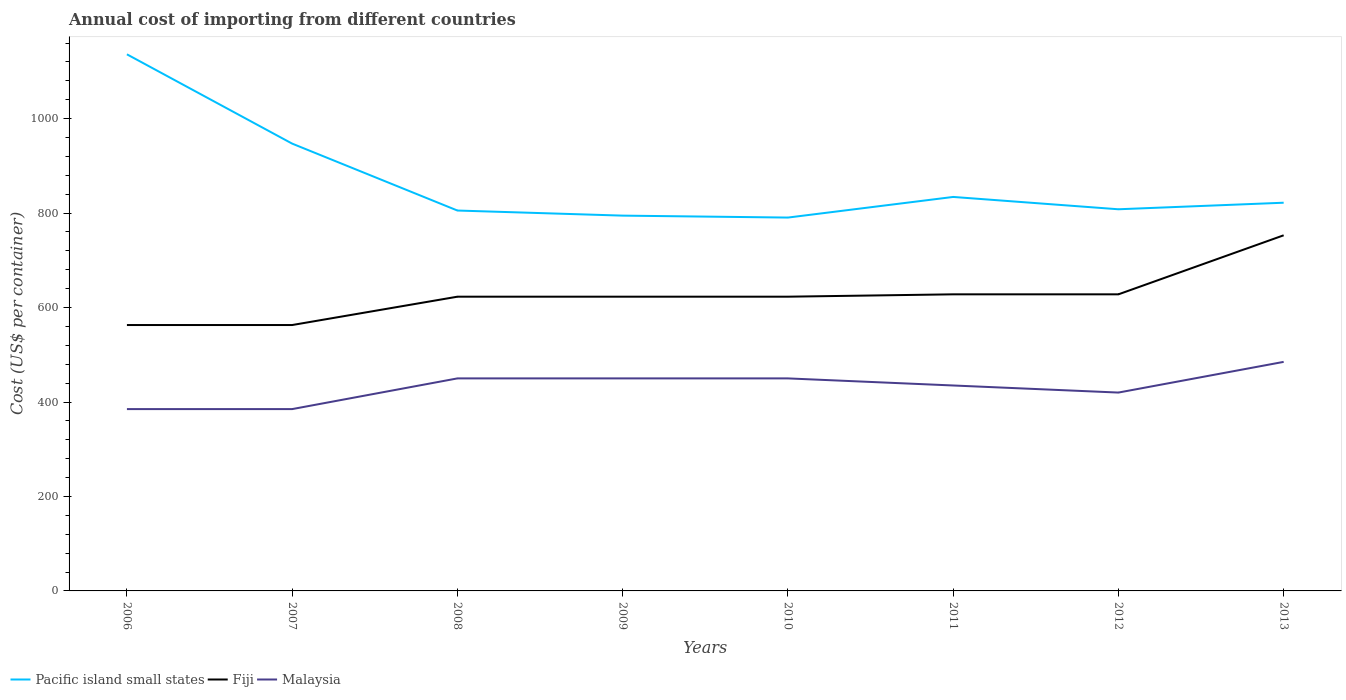Does the line corresponding to Pacific island small states intersect with the line corresponding to Fiji?
Offer a very short reply. No. Is the number of lines equal to the number of legend labels?
Provide a succinct answer. Yes. Across all years, what is the maximum total annual cost of importing in Fiji?
Your response must be concise. 563. What is the total total annual cost of importing in Malaysia in the graph?
Offer a terse response. -50. What is the difference between the highest and the second highest total annual cost of importing in Pacific island small states?
Offer a very short reply. 345.67. How many lines are there?
Provide a short and direct response. 3. How many years are there in the graph?
Your response must be concise. 8. What is the difference between two consecutive major ticks on the Y-axis?
Ensure brevity in your answer.  200. Does the graph contain grids?
Provide a short and direct response. No. Where does the legend appear in the graph?
Provide a succinct answer. Bottom left. How are the legend labels stacked?
Your answer should be very brief. Horizontal. What is the title of the graph?
Your answer should be compact. Annual cost of importing from different countries. What is the label or title of the X-axis?
Make the answer very short. Years. What is the label or title of the Y-axis?
Make the answer very short. Cost (US$ per container). What is the Cost (US$ per container) in Pacific island small states in 2006?
Offer a very short reply. 1136.22. What is the Cost (US$ per container) in Fiji in 2006?
Your answer should be very brief. 563. What is the Cost (US$ per container) in Malaysia in 2006?
Keep it short and to the point. 385. What is the Cost (US$ per container) in Pacific island small states in 2007?
Your answer should be compact. 947.11. What is the Cost (US$ per container) of Fiji in 2007?
Keep it short and to the point. 563. What is the Cost (US$ per container) of Malaysia in 2007?
Make the answer very short. 385. What is the Cost (US$ per container) in Pacific island small states in 2008?
Your answer should be very brief. 805.44. What is the Cost (US$ per container) of Fiji in 2008?
Ensure brevity in your answer.  623. What is the Cost (US$ per container) in Malaysia in 2008?
Your answer should be very brief. 450. What is the Cost (US$ per container) in Pacific island small states in 2009?
Keep it short and to the point. 794.67. What is the Cost (US$ per container) in Fiji in 2009?
Make the answer very short. 623. What is the Cost (US$ per container) of Malaysia in 2009?
Give a very brief answer. 450. What is the Cost (US$ per container) of Pacific island small states in 2010?
Give a very brief answer. 790.56. What is the Cost (US$ per container) in Fiji in 2010?
Your answer should be compact. 623. What is the Cost (US$ per container) of Malaysia in 2010?
Offer a very short reply. 450. What is the Cost (US$ per container) of Pacific island small states in 2011?
Make the answer very short. 834.22. What is the Cost (US$ per container) of Fiji in 2011?
Give a very brief answer. 628. What is the Cost (US$ per container) of Malaysia in 2011?
Provide a short and direct response. 435. What is the Cost (US$ per container) of Pacific island small states in 2012?
Make the answer very short. 808.11. What is the Cost (US$ per container) in Fiji in 2012?
Provide a short and direct response. 628. What is the Cost (US$ per container) of Malaysia in 2012?
Offer a very short reply. 420. What is the Cost (US$ per container) in Pacific island small states in 2013?
Provide a succinct answer. 822. What is the Cost (US$ per container) in Fiji in 2013?
Make the answer very short. 753. What is the Cost (US$ per container) of Malaysia in 2013?
Offer a terse response. 485. Across all years, what is the maximum Cost (US$ per container) in Pacific island small states?
Your response must be concise. 1136.22. Across all years, what is the maximum Cost (US$ per container) in Fiji?
Give a very brief answer. 753. Across all years, what is the maximum Cost (US$ per container) in Malaysia?
Your answer should be compact. 485. Across all years, what is the minimum Cost (US$ per container) of Pacific island small states?
Your response must be concise. 790.56. Across all years, what is the minimum Cost (US$ per container) in Fiji?
Keep it short and to the point. 563. Across all years, what is the minimum Cost (US$ per container) in Malaysia?
Your answer should be compact. 385. What is the total Cost (US$ per container) of Pacific island small states in the graph?
Your answer should be very brief. 6938.33. What is the total Cost (US$ per container) of Fiji in the graph?
Provide a short and direct response. 5004. What is the total Cost (US$ per container) in Malaysia in the graph?
Your answer should be very brief. 3460. What is the difference between the Cost (US$ per container) in Pacific island small states in 2006 and that in 2007?
Provide a succinct answer. 189.11. What is the difference between the Cost (US$ per container) of Fiji in 2006 and that in 2007?
Give a very brief answer. 0. What is the difference between the Cost (US$ per container) of Pacific island small states in 2006 and that in 2008?
Keep it short and to the point. 330.78. What is the difference between the Cost (US$ per container) in Fiji in 2006 and that in 2008?
Give a very brief answer. -60. What is the difference between the Cost (US$ per container) of Malaysia in 2006 and that in 2008?
Keep it short and to the point. -65. What is the difference between the Cost (US$ per container) of Pacific island small states in 2006 and that in 2009?
Offer a terse response. 341.56. What is the difference between the Cost (US$ per container) in Fiji in 2006 and that in 2009?
Provide a short and direct response. -60. What is the difference between the Cost (US$ per container) in Malaysia in 2006 and that in 2009?
Give a very brief answer. -65. What is the difference between the Cost (US$ per container) in Pacific island small states in 2006 and that in 2010?
Give a very brief answer. 345.67. What is the difference between the Cost (US$ per container) of Fiji in 2006 and that in 2010?
Give a very brief answer. -60. What is the difference between the Cost (US$ per container) in Malaysia in 2006 and that in 2010?
Offer a very short reply. -65. What is the difference between the Cost (US$ per container) in Pacific island small states in 2006 and that in 2011?
Keep it short and to the point. 302. What is the difference between the Cost (US$ per container) of Fiji in 2006 and that in 2011?
Your answer should be very brief. -65. What is the difference between the Cost (US$ per container) in Malaysia in 2006 and that in 2011?
Provide a succinct answer. -50. What is the difference between the Cost (US$ per container) in Pacific island small states in 2006 and that in 2012?
Your response must be concise. 328.11. What is the difference between the Cost (US$ per container) in Fiji in 2006 and that in 2012?
Your response must be concise. -65. What is the difference between the Cost (US$ per container) of Malaysia in 2006 and that in 2012?
Ensure brevity in your answer.  -35. What is the difference between the Cost (US$ per container) in Pacific island small states in 2006 and that in 2013?
Give a very brief answer. 314.22. What is the difference between the Cost (US$ per container) of Fiji in 2006 and that in 2013?
Keep it short and to the point. -190. What is the difference between the Cost (US$ per container) in Malaysia in 2006 and that in 2013?
Make the answer very short. -100. What is the difference between the Cost (US$ per container) in Pacific island small states in 2007 and that in 2008?
Provide a short and direct response. 141.67. What is the difference between the Cost (US$ per container) of Fiji in 2007 and that in 2008?
Provide a short and direct response. -60. What is the difference between the Cost (US$ per container) of Malaysia in 2007 and that in 2008?
Keep it short and to the point. -65. What is the difference between the Cost (US$ per container) in Pacific island small states in 2007 and that in 2009?
Your answer should be compact. 152.44. What is the difference between the Cost (US$ per container) of Fiji in 2007 and that in 2009?
Your answer should be compact. -60. What is the difference between the Cost (US$ per container) of Malaysia in 2007 and that in 2009?
Your answer should be compact. -65. What is the difference between the Cost (US$ per container) in Pacific island small states in 2007 and that in 2010?
Keep it short and to the point. 156.56. What is the difference between the Cost (US$ per container) of Fiji in 2007 and that in 2010?
Ensure brevity in your answer.  -60. What is the difference between the Cost (US$ per container) in Malaysia in 2007 and that in 2010?
Offer a terse response. -65. What is the difference between the Cost (US$ per container) in Pacific island small states in 2007 and that in 2011?
Your response must be concise. 112.89. What is the difference between the Cost (US$ per container) of Fiji in 2007 and that in 2011?
Make the answer very short. -65. What is the difference between the Cost (US$ per container) in Pacific island small states in 2007 and that in 2012?
Offer a very short reply. 139. What is the difference between the Cost (US$ per container) of Fiji in 2007 and that in 2012?
Offer a terse response. -65. What is the difference between the Cost (US$ per container) in Malaysia in 2007 and that in 2012?
Ensure brevity in your answer.  -35. What is the difference between the Cost (US$ per container) in Pacific island small states in 2007 and that in 2013?
Your response must be concise. 125.11. What is the difference between the Cost (US$ per container) in Fiji in 2007 and that in 2013?
Provide a succinct answer. -190. What is the difference between the Cost (US$ per container) in Malaysia in 2007 and that in 2013?
Your answer should be compact. -100. What is the difference between the Cost (US$ per container) of Pacific island small states in 2008 and that in 2009?
Ensure brevity in your answer.  10.78. What is the difference between the Cost (US$ per container) in Fiji in 2008 and that in 2009?
Give a very brief answer. 0. What is the difference between the Cost (US$ per container) in Pacific island small states in 2008 and that in 2010?
Offer a terse response. 14.89. What is the difference between the Cost (US$ per container) in Malaysia in 2008 and that in 2010?
Give a very brief answer. 0. What is the difference between the Cost (US$ per container) of Pacific island small states in 2008 and that in 2011?
Give a very brief answer. -28.78. What is the difference between the Cost (US$ per container) in Fiji in 2008 and that in 2011?
Offer a terse response. -5. What is the difference between the Cost (US$ per container) of Pacific island small states in 2008 and that in 2012?
Provide a short and direct response. -2.67. What is the difference between the Cost (US$ per container) in Malaysia in 2008 and that in 2012?
Your answer should be compact. 30. What is the difference between the Cost (US$ per container) in Pacific island small states in 2008 and that in 2013?
Ensure brevity in your answer.  -16.56. What is the difference between the Cost (US$ per container) in Fiji in 2008 and that in 2013?
Your answer should be very brief. -130. What is the difference between the Cost (US$ per container) of Malaysia in 2008 and that in 2013?
Offer a terse response. -35. What is the difference between the Cost (US$ per container) of Pacific island small states in 2009 and that in 2010?
Offer a very short reply. 4.11. What is the difference between the Cost (US$ per container) in Malaysia in 2009 and that in 2010?
Ensure brevity in your answer.  0. What is the difference between the Cost (US$ per container) of Pacific island small states in 2009 and that in 2011?
Your response must be concise. -39.56. What is the difference between the Cost (US$ per container) of Pacific island small states in 2009 and that in 2012?
Keep it short and to the point. -13.44. What is the difference between the Cost (US$ per container) in Fiji in 2009 and that in 2012?
Ensure brevity in your answer.  -5. What is the difference between the Cost (US$ per container) of Malaysia in 2009 and that in 2012?
Your answer should be very brief. 30. What is the difference between the Cost (US$ per container) in Pacific island small states in 2009 and that in 2013?
Keep it short and to the point. -27.33. What is the difference between the Cost (US$ per container) in Fiji in 2009 and that in 2013?
Offer a terse response. -130. What is the difference between the Cost (US$ per container) in Malaysia in 2009 and that in 2013?
Ensure brevity in your answer.  -35. What is the difference between the Cost (US$ per container) of Pacific island small states in 2010 and that in 2011?
Your answer should be compact. -43.67. What is the difference between the Cost (US$ per container) of Malaysia in 2010 and that in 2011?
Your answer should be very brief. 15. What is the difference between the Cost (US$ per container) of Pacific island small states in 2010 and that in 2012?
Your answer should be compact. -17.56. What is the difference between the Cost (US$ per container) in Pacific island small states in 2010 and that in 2013?
Keep it short and to the point. -31.44. What is the difference between the Cost (US$ per container) in Fiji in 2010 and that in 2013?
Give a very brief answer. -130. What is the difference between the Cost (US$ per container) of Malaysia in 2010 and that in 2013?
Keep it short and to the point. -35. What is the difference between the Cost (US$ per container) in Pacific island small states in 2011 and that in 2012?
Your response must be concise. 26.11. What is the difference between the Cost (US$ per container) of Pacific island small states in 2011 and that in 2013?
Keep it short and to the point. 12.22. What is the difference between the Cost (US$ per container) in Fiji in 2011 and that in 2013?
Provide a succinct answer. -125. What is the difference between the Cost (US$ per container) of Pacific island small states in 2012 and that in 2013?
Offer a very short reply. -13.89. What is the difference between the Cost (US$ per container) of Fiji in 2012 and that in 2013?
Provide a short and direct response. -125. What is the difference between the Cost (US$ per container) of Malaysia in 2012 and that in 2013?
Offer a terse response. -65. What is the difference between the Cost (US$ per container) in Pacific island small states in 2006 and the Cost (US$ per container) in Fiji in 2007?
Give a very brief answer. 573.22. What is the difference between the Cost (US$ per container) of Pacific island small states in 2006 and the Cost (US$ per container) of Malaysia in 2007?
Ensure brevity in your answer.  751.22. What is the difference between the Cost (US$ per container) in Fiji in 2006 and the Cost (US$ per container) in Malaysia in 2007?
Keep it short and to the point. 178. What is the difference between the Cost (US$ per container) in Pacific island small states in 2006 and the Cost (US$ per container) in Fiji in 2008?
Give a very brief answer. 513.22. What is the difference between the Cost (US$ per container) of Pacific island small states in 2006 and the Cost (US$ per container) of Malaysia in 2008?
Your answer should be very brief. 686.22. What is the difference between the Cost (US$ per container) in Fiji in 2006 and the Cost (US$ per container) in Malaysia in 2008?
Provide a short and direct response. 113. What is the difference between the Cost (US$ per container) in Pacific island small states in 2006 and the Cost (US$ per container) in Fiji in 2009?
Offer a terse response. 513.22. What is the difference between the Cost (US$ per container) of Pacific island small states in 2006 and the Cost (US$ per container) of Malaysia in 2009?
Give a very brief answer. 686.22. What is the difference between the Cost (US$ per container) in Fiji in 2006 and the Cost (US$ per container) in Malaysia in 2009?
Provide a short and direct response. 113. What is the difference between the Cost (US$ per container) in Pacific island small states in 2006 and the Cost (US$ per container) in Fiji in 2010?
Give a very brief answer. 513.22. What is the difference between the Cost (US$ per container) of Pacific island small states in 2006 and the Cost (US$ per container) of Malaysia in 2010?
Provide a short and direct response. 686.22. What is the difference between the Cost (US$ per container) in Fiji in 2006 and the Cost (US$ per container) in Malaysia in 2010?
Give a very brief answer. 113. What is the difference between the Cost (US$ per container) in Pacific island small states in 2006 and the Cost (US$ per container) in Fiji in 2011?
Offer a terse response. 508.22. What is the difference between the Cost (US$ per container) of Pacific island small states in 2006 and the Cost (US$ per container) of Malaysia in 2011?
Your response must be concise. 701.22. What is the difference between the Cost (US$ per container) in Fiji in 2006 and the Cost (US$ per container) in Malaysia in 2011?
Give a very brief answer. 128. What is the difference between the Cost (US$ per container) of Pacific island small states in 2006 and the Cost (US$ per container) of Fiji in 2012?
Give a very brief answer. 508.22. What is the difference between the Cost (US$ per container) in Pacific island small states in 2006 and the Cost (US$ per container) in Malaysia in 2012?
Provide a short and direct response. 716.22. What is the difference between the Cost (US$ per container) in Fiji in 2006 and the Cost (US$ per container) in Malaysia in 2012?
Offer a very short reply. 143. What is the difference between the Cost (US$ per container) in Pacific island small states in 2006 and the Cost (US$ per container) in Fiji in 2013?
Offer a terse response. 383.22. What is the difference between the Cost (US$ per container) of Pacific island small states in 2006 and the Cost (US$ per container) of Malaysia in 2013?
Provide a succinct answer. 651.22. What is the difference between the Cost (US$ per container) in Pacific island small states in 2007 and the Cost (US$ per container) in Fiji in 2008?
Your answer should be very brief. 324.11. What is the difference between the Cost (US$ per container) in Pacific island small states in 2007 and the Cost (US$ per container) in Malaysia in 2008?
Make the answer very short. 497.11. What is the difference between the Cost (US$ per container) of Fiji in 2007 and the Cost (US$ per container) of Malaysia in 2008?
Provide a succinct answer. 113. What is the difference between the Cost (US$ per container) in Pacific island small states in 2007 and the Cost (US$ per container) in Fiji in 2009?
Provide a succinct answer. 324.11. What is the difference between the Cost (US$ per container) of Pacific island small states in 2007 and the Cost (US$ per container) of Malaysia in 2009?
Provide a short and direct response. 497.11. What is the difference between the Cost (US$ per container) in Fiji in 2007 and the Cost (US$ per container) in Malaysia in 2009?
Ensure brevity in your answer.  113. What is the difference between the Cost (US$ per container) in Pacific island small states in 2007 and the Cost (US$ per container) in Fiji in 2010?
Make the answer very short. 324.11. What is the difference between the Cost (US$ per container) of Pacific island small states in 2007 and the Cost (US$ per container) of Malaysia in 2010?
Offer a terse response. 497.11. What is the difference between the Cost (US$ per container) of Fiji in 2007 and the Cost (US$ per container) of Malaysia in 2010?
Your answer should be very brief. 113. What is the difference between the Cost (US$ per container) of Pacific island small states in 2007 and the Cost (US$ per container) of Fiji in 2011?
Your answer should be very brief. 319.11. What is the difference between the Cost (US$ per container) in Pacific island small states in 2007 and the Cost (US$ per container) in Malaysia in 2011?
Your answer should be very brief. 512.11. What is the difference between the Cost (US$ per container) in Fiji in 2007 and the Cost (US$ per container) in Malaysia in 2011?
Provide a short and direct response. 128. What is the difference between the Cost (US$ per container) of Pacific island small states in 2007 and the Cost (US$ per container) of Fiji in 2012?
Keep it short and to the point. 319.11. What is the difference between the Cost (US$ per container) in Pacific island small states in 2007 and the Cost (US$ per container) in Malaysia in 2012?
Give a very brief answer. 527.11. What is the difference between the Cost (US$ per container) of Fiji in 2007 and the Cost (US$ per container) of Malaysia in 2012?
Offer a terse response. 143. What is the difference between the Cost (US$ per container) of Pacific island small states in 2007 and the Cost (US$ per container) of Fiji in 2013?
Ensure brevity in your answer.  194.11. What is the difference between the Cost (US$ per container) in Pacific island small states in 2007 and the Cost (US$ per container) in Malaysia in 2013?
Make the answer very short. 462.11. What is the difference between the Cost (US$ per container) of Pacific island small states in 2008 and the Cost (US$ per container) of Fiji in 2009?
Keep it short and to the point. 182.44. What is the difference between the Cost (US$ per container) in Pacific island small states in 2008 and the Cost (US$ per container) in Malaysia in 2009?
Your response must be concise. 355.44. What is the difference between the Cost (US$ per container) in Fiji in 2008 and the Cost (US$ per container) in Malaysia in 2009?
Your answer should be compact. 173. What is the difference between the Cost (US$ per container) in Pacific island small states in 2008 and the Cost (US$ per container) in Fiji in 2010?
Provide a succinct answer. 182.44. What is the difference between the Cost (US$ per container) in Pacific island small states in 2008 and the Cost (US$ per container) in Malaysia in 2010?
Provide a short and direct response. 355.44. What is the difference between the Cost (US$ per container) in Fiji in 2008 and the Cost (US$ per container) in Malaysia in 2010?
Ensure brevity in your answer.  173. What is the difference between the Cost (US$ per container) in Pacific island small states in 2008 and the Cost (US$ per container) in Fiji in 2011?
Provide a short and direct response. 177.44. What is the difference between the Cost (US$ per container) of Pacific island small states in 2008 and the Cost (US$ per container) of Malaysia in 2011?
Provide a succinct answer. 370.44. What is the difference between the Cost (US$ per container) of Fiji in 2008 and the Cost (US$ per container) of Malaysia in 2011?
Ensure brevity in your answer.  188. What is the difference between the Cost (US$ per container) in Pacific island small states in 2008 and the Cost (US$ per container) in Fiji in 2012?
Ensure brevity in your answer.  177.44. What is the difference between the Cost (US$ per container) of Pacific island small states in 2008 and the Cost (US$ per container) of Malaysia in 2012?
Ensure brevity in your answer.  385.44. What is the difference between the Cost (US$ per container) of Fiji in 2008 and the Cost (US$ per container) of Malaysia in 2012?
Your answer should be very brief. 203. What is the difference between the Cost (US$ per container) of Pacific island small states in 2008 and the Cost (US$ per container) of Fiji in 2013?
Keep it short and to the point. 52.44. What is the difference between the Cost (US$ per container) of Pacific island small states in 2008 and the Cost (US$ per container) of Malaysia in 2013?
Your answer should be very brief. 320.44. What is the difference between the Cost (US$ per container) in Fiji in 2008 and the Cost (US$ per container) in Malaysia in 2013?
Ensure brevity in your answer.  138. What is the difference between the Cost (US$ per container) in Pacific island small states in 2009 and the Cost (US$ per container) in Fiji in 2010?
Offer a very short reply. 171.67. What is the difference between the Cost (US$ per container) in Pacific island small states in 2009 and the Cost (US$ per container) in Malaysia in 2010?
Your response must be concise. 344.67. What is the difference between the Cost (US$ per container) of Fiji in 2009 and the Cost (US$ per container) of Malaysia in 2010?
Provide a succinct answer. 173. What is the difference between the Cost (US$ per container) in Pacific island small states in 2009 and the Cost (US$ per container) in Fiji in 2011?
Provide a succinct answer. 166.67. What is the difference between the Cost (US$ per container) of Pacific island small states in 2009 and the Cost (US$ per container) of Malaysia in 2011?
Your response must be concise. 359.67. What is the difference between the Cost (US$ per container) in Fiji in 2009 and the Cost (US$ per container) in Malaysia in 2011?
Make the answer very short. 188. What is the difference between the Cost (US$ per container) of Pacific island small states in 2009 and the Cost (US$ per container) of Fiji in 2012?
Give a very brief answer. 166.67. What is the difference between the Cost (US$ per container) of Pacific island small states in 2009 and the Cost (US$ per container) of Malaysia in 2012?
Provide a succinct answer. 374.67. What is the difference between the Cost (US$ per container) of Fiji in 2009 and the Cost (US$ per container) of Malaysia in 2012?
Keep it short and to the point. 203. What is the difference between the Cost (US$ per container) in Pacific island small states in 2009 and the Cost (US$ per container) in Fiji in 2013?
Your answer should be very brief. 41.67. What is the difference between the Cost (US$ per container) of Pacific island small states in 2009 and the Cost (US$ per container) of Malaysia in 2013?
Provide a short and direct response. 309.67. What is the difference between the Cost (US$ per container) of Fiji in 2009 and the Cost (US$ per container) of Malaysia in 2013?
Offer a very short reply. 138. What is the difference between the Cost (US$ per container) in Pacific island small states in 2010 and the Cost (US$ per container) in Fiji in 2011?
Your answer should be compact. 162.56. What is the difference between the Cost (US$ per container) of Pacific island small states in 2010 and the Cost (US$ per container) of Malaysia in 2011?
Your answer should be very brief. 355.56. What is the difference between the Cost (US$ per container) of Fiji in 2010 and the Cost (US$ per container) of Malaysia in 2011?
Offer a very short reply. 188. What is the difference between the Cost (US$ per container) in Pacific island small states in 2010 and the Cost (US$ per container) in Fiji in 2012?
Give a very brief answer. 162.56. What is the difference between the Cost (US$ per container) of Pacific island small states in 2010 and the Cost (US$ per container) of Malaysia in 2012?
Provide a succinct answer. 370.56. What is the difference between the Cost (US$ per container) of Fiji in 2010 and the Cost (US$ per container) of Malaysia in 2012?
Keep it short and to the point. 203. What is the difference between the Cost (US$ per container) in Pacific island small states in 2010 and the Cost (US$ per container) in Fiji in 2013?
Keep it short and to the point. 37.56. What is the difference between the Cost (US$ per container) of Pacific island small states in 2010 and the Cost (US$ per container) of Malaysia in 2013?
Provide a short and direct response. 305.56. What is the difference between the Cost (US$ per container) of Fiji in 2010 and the Cost (US$ per container) of Malaysia in 2013?
Provide a succinct answer. 138. What is the difference between the Cost (US$ per container) of Pacific island small states in 2011 and the Cost (US$ per container) of Fiji in 2012?
Your response must be concise. 206.22. What is the difference between the Cost (US$ per container) of Pacific island small states in 2011 and the Cost (US$ per container) of Malaysia in 2012?
Offer a very short reply. 414.22. What is the difference between the Cost (US$ per container) of Fiji in 2011 and the Cost (US$ per container) of Malaysia in 2012?
Give a very brief answer. 208. What is the difference between the Cost (US$ per container) in Pacific island small states in 2011 and the Cost (US$ per container) in Fiji in 2013?
Keep it short and to the point. 81.22. What is the difference between the Cost (US$ per container) in Pacific island small states in 2011 and the Cost (US$ per container) in Malaysia in 2013?
Ensure brevity in your answer.  349.22. What is the difference between the Cost (US$ per container) in Fiji in 2011 and the Cost (US$ per container) in Malaysia in 2013?
Give a very brief answer. 143. What is the difference between the Cost (US$ per container) of Pacific island small states in 2012 and the Cost (US$ per container) of Fiji in 2013?
Your answer should be very brief. 55.11. What is the difference between the Cost (US$ per container) in Pacific island small states in 2012 and the Cost (US$ per container) in Malaysia in 2013?
Provide a short and direct response. 323.11. What is the difference between the Cost (US$ per container) in Fiji in 2012 and the Cost (US$ per container) in Malaysia in 2013?
Offer a very short reply. 143. What is the average Cost (US$ per container) of Pacific island small states per year?
Give a very brief answer. 867.29. What is the average Cost (US$ per container) in Fiji per year?
Your response must be concise. 625.5. What is the average Cost (US$ per container) of Malaysia per year?
Ensure brevity in your answer.  432.5. In the year 2006, what is the difference between the Cost (US$ per container) of Pacific island small states and Cost (US$ per container) of Fiji?
Your answer should be very brief. 573.22. In the year 2006, what is the difference between the Cost (US$ per container) in Pacific island small states and Cost (US$ per container) in Malaysia?
Make the answer very short. 751.22. In the year 2006, what is the difference between the Cost (US$ per container) in Fiji and Cost (US$ per container) in Malaysia?
Your answer should be compact. 178. In the year 2007, what is the difference between the Cost (US$ per container) in Pacific island small states and Cost (US$ per container) in Fiji?
Make the answer very short. 384.11. In the year 2007, what is the difference between the Cost (US$ per container) in Pacific island small states and Cost (US$ per container) in Malaysia?
Keep it short and to the point. 562.11. In the year 2007, what is the difference between the Cost (US$ per container) in Fiji and Cost (US$ per container) in Malaysia?
Your answer should be compact. 178. In the year 2008, what is the difference between the Cost (US$ per container) of Pacific island small states and Cost (US$ per container) of Fiji?
Keep it short and to the point. 182.44. In the year 2008, what is the difference between the Cost (US$ per container) in Pacific island small states and Cost (US$ per container) in Malaysia?
Make the answer very short. 355.44. In the year 2008, what is the difference between the Cost (US$ per container) in Fiji and Cost (US$ per container) in Malaysia?
Offer a terse response. 173. In the year 2009, what is the difference between the Cost (US$ per container) of Pacific island small states and Cost (US$ per container) of Fiji?
Offer a very short reply. 171.67. In the year 2009, what is the difference between the Cost (US$ per container) of Pacific island small states and Cost (US$ per container) of Malaysia?
Provide a succinct answer. 344.67. In the year 2009, what is the difference between the Cost (US$ per container) of Fiji and Cost (US$ per container) of Malaysia?
Your response must be concise. 173. In the year 2010, what is the difference between the Cost (US$ per container) of Pacific island small states and Cost (US$ per container) of Fiji?
Your response must be concise. 167.56. In the year 2010, what is the difference between the Cost (US$ per container) in Pacific island small states and Cost (US$ per container) in Malaysia?
Keep it short and to the point. 340.56. In the year 2010, what is the difference between the Cost (US$ per container) in Fiji and Cost (US$ per container) in Malaysia?
Ensure brevity in your answer.  173. In the year 2011, what is the difference between the Cost (US$ per container) of Pacific island small states and Cost (US$ per container) of Fiji?
Your response must be concise. 206.22. In the year 2011, what is the difference between the Cost (US$ per container) of Pacific island small states and Cost (US$ per container) of Malaysia?
Your answer should be compact. 399.22. In the year 2011, what is the difference between the Cost (US$ per container) in Fiji and Cost (US$ per container) in Malaysia?
Make the answer very short. 193. In the year 2012, what is the difference between the Cost (US$ per container) in Pacific island small states and Cost (US$ per container) in Fiji?
Your answer should be compact. 180.11. In the year 2012, what is the difference between the Cost (US$ per container) of Pacific island small states and Cost (US$ per container) of Malaysia?
Offer a very short reply. 388.11. In the year 2012, what is the difference between the Cost (US$ per container) of Fiji and Cost (US$ per container) of Malaysia?
Keep it short and to the point. 208. In the year 2013, what is the difference between the Cost (US$ per container) of Pacific island small states and Cost (US$ per container) of Fiji?
Your response must be concise. 69. In the year 2013, what is the difference between the Cost (US$ per container) in Pacific island small states and Cost (US$ per container) in Malaysia?
Make the answer very short. 337. In the year 2013, what is the difference between the Cost (US$ per container) of Fiji and Cost (US$ per container) of Malaysia?
Keep it short and to the point. 268. What is the ratio of the Cost (US$ per container) in Pacific island small states in 2006 to that in 2007?
Provide a succinct answer. 1.2. What is the ratio of the Cost (US$ per container) of Fiji in 2006 to that in 2007?
Ensure brevity in your answer.  1. What is the ratio of the Cost (US$ per container) in Malaysia in 2006 to that in 2007?
Keep it short and to the point. 1. What is the ratio of the Cost (US$ per container) in Pacific island small states in 2006 to that in 2008?
Give a very brief answer. 1.41. What is the ratio of the Cost (US$ per container) of Fiji in 2006 to that in 2008?
Give a very brief answer. 0.9. What is the ratio of the Cost (US$ per container) in Malaysia in 2006 to that in 2008?
Make the answer very short. 0.86. What is the ratio of the Cost (US$ per container) in Pacific island small states in 2006 to that in 2009?
Provide a short and direct response. 1.43. What is the ratio of the Cost (US$ per container) in Fiji in 2006 to that in 2009?
Keep it short and to the point. 0.9. What is the ratio of the Cost (US$ per container) of Malaysia in 2006 to that in 2009?
Make the answer very short. 0.86. What is the ratio of the Cost (US$ per container) of Pacific island small states in 2006 to that in 2010?
Make the answer very short. 1.44. What is the ratio of the Cost (US$ per container) of Fiji in 2006 to that in 2010?
Provide a short and direct response. 0.9. What is the ratio of the Cost (US$ per container) of Malaysia in 2006 to that in 2010?
Offer a terse response. 0.86. What is the ratio of the Cost (US$ per container) of Pacific island small states in 2006 to that in 2011?
Your answer should be compact. 1.36. What is the ratio of the Cost (US$ per container) of Fiji in 2006 to that in 2011?
Your answer should be very brief. 0.9. What is the ratio of the Cost (US$ per container) of Malaysia in 2006 to that in 2011?
Ensure brevity in your answer.  0.89. What is the ratio of the Cost (US$ per container) in Pacific island small states in 2006 to that in 2012?
Offer a very short reply. 1.41. What is the ratio of the Cost (US$ per container) in Fiji in 2006 to that in 2012?
Your answer should be very brief. 0.9. What is the ratio of the Cost (US$ per container) of Malaysia in 2006 to that in 2012?
Ensure brevity in your answer.  0.92. What is the ratio of the Cost (US$ per container) in Pacific island small states in 2006 to that in 2013?
Your answer should be compact. 1.38. What is the ratio of the Cost (US$ per container) of Fiji in 2006 to that in 2013?
Ensure brevity in your answer.  0.75. What is the ratio of the Cost (US$ per container) in Malaysia in 2006 to that in 2013?
Offer a terse response. 0.79. What is the ratio of the Cost (US$ per container) of Pacific island small states in 2007 to that in 2008?
Give a very brief answer. 1.18. What is the ratio of the Cost (US$ per container) in Fiji in 2007 to that in 2008?
Ensure brevity in your answer.  0.9. What is the ratio of the Cost (US$ per container) of Malaysia in 2007 to that in 2008?
Provide a succinct answer. 0.86. What is the ratio of the Cost (US$ per container) in Pacific island small states in 2007 to that in 2009?
Provide a succinct answer. 1.19. What is the ratio of the Cost (US$ per container) in Fiji in 2007 to that in 2009?
Provide a succinct answer. 0.9. What is the ratio of the Cost (US$ per container) in Malaysia in 2007 to that in 2009?
Your answer should be very brief. 0.86. What is the ratio of the Cost (US$ per container) of Pacific island small states in 2007 to that in 2010?
Your answer should be very brief. 1.2. What is the ratio of the Cost (US$ per container) in Fiji in 2007 to that in 2010?
Provide a succinct answer. 0.9. What is the ratio of the Cost (US$ per container) of Malaysia in 2007 to that in 2010?
Provide a short and direct response. 0.86. What is the ratio of the Cost (US$ per container) of Pacific island small states in 2007 to that in 2011?
Offer a very short reply. 1.14. What is the ratio of the Cost (US$ per container) in Fiji in 2007 to that in 2011?
Your response must be concise. 0.9. What is the ratio of the Cost (US$ per container) in Malaysia in 2007 to that in 2011?
Give a very brief answer. 0.89. What is the ratio of the Cost (US$ per container) in Pacific island small states in 2007 to that in 2012?
Your answer should be very brief. 1.17. What is the ratio of the Cost (US$ per container) of Fiji in 2007 to that in 2012?
Ensure brevity in your answer.  0.9. What is the ratio of the Cost (US$ per container) of Malaysia in 2007 to that in 2012?
Ensure brevity in your answer.  0.92. What is the ratio of the Cost (US$ per container) of Pacific island small states in 2007 to that in 2013?
Offer a very short reply. 1.15. What is the ratio of the Cost (US$ per container) in Fiji in 2007 to that in 2013?
Provide a succinct answer. 0.75. What is the ratio of the Cost (US$ per container) of Malaysia in 2007 to that in 2013?
Your answer should be very brief. 0.79. What is the ratio of the Cost (US$ per container) of Pacific island small states in 2008 to that in 2009?
Offer a terse response. 1.01. What is the ratio of the Cost (US$ per container) of Pacific island small states in 2008 to that in 2010?
Your response must be concise. 1.02. What is the ratio of the Cost (US$ per container) in Fiji in 2008 to that in 2010?
Ensure brevity in your answer.  1. What is the ratio of the Cost (US$ per container) in Pacific island small states in 2008 to that in 2011?
Ensure brevity in your answer.  0.97. What is the ratio of the Cost (US$ per container) in Malaysia in 2008 to that in 2011?
Offer a very short reply. 1.03. What is the ratio of the Cost (US$ per container) of Malaysia in 2008 to that in 2012?
Offer a very short reply. 1.07. What is the ratio of the Cost (US$ per container) of Pacific island small states in 2008 to that in 2013?
Provide a short and direct response. 0.98. What is the ratio of the Cost (US$ per container) of Fiji in 2008 to that in 2013?
Give a very brief answer. 0.83. What is the ratio of the Cost (US$ per container) in Malaysia in 2008 to that in 2013?
Make the answer very short. 0.93. What is the ratio of the Cost (US$ per container) of Pacific island small states in 2009 to that in 2010?
Provide a short and direct response. 1.01. What is the ratio of the Cost (US$ per container) of Pacific island small states in 2009 to that in 2011?
Your response must be concise. 0.95. What is the ratio of the Cost (US$ per container) of Fiji in 2009 to that in 2011?
Your response must be concise. 0.99. What is the ratio of the Cost (US$ per container) in Malaysia in 2009 to that in 2011?
Your response must be concise. 1.03. What is the ratio of the Cost (US$ per container) in Pacific island small states in 2009 to that in 2012?
Keep it short and to the point. 0.98. What is the ratio of the Cost (US$ per container) of Malaysia in 2009 to that in 2012?
Your response must be concise. 1.07. What is the ratio of the Cost (US$ per container) of Pacific island small states in 2009 to that in 2013?
Ensure brevity in your answer.  0.97. What is the ratio of the Cost (US$ per container) in Fiji in 2009 to that in 2013?
Offer a terse response. 0.83. What is the ratio of the Cost (US$ per container) of Malaysia in 2009 to that in 2013?
Your response must be concise. 0.93. What is the ratio of the Cost (US$ per container) in Pacific island small states in 2010 to that in 2011?
Offer a terse response. 0.95. What is the ratio of the Cost (US$ per container) in Fiji in 2010 to that in 2011?
Your response must be concise. 0.99. What is the ratio of the Cost (US$ per container) of Malaysia in 2010 to that in 2011?
Provide a short and direct response. 1.03. What is the ratio of the Cost (US$ per container) of Pacific island small states in 2010 to that in 2012?
Offer a terse response. 0.98. What is the ratio of the Cost (US$ per container) in Fiji in 2010 to that in 2012?
Give a very brief answer. 0.99. What is the ratio of the Cost (US$ per container) in Malaysia in 2010 to that in 2012?
Provide a succinct answer. 1.07. What is the ratio of the Cost (US$ per container) of Pacific island small states in 2010 to that in 2013?
Your answer should be very brief. 0.96. What is the ratio of the Cost (US$ per container) in Fiji in 2010 to that in 2013?
Offer a very short reply. 0.83. What is the ratio of the Cost (US$ per container) in Malaysia in 2010 to that in 2013?
Keep it short and to the point. 0.93. What is the ratio of the Cost (US$ per container) in Pacific island small states in 2011 to that in 2012?
Give a very brief answer. 1.03. What is the ratio of the Cost (US$ per container) of Fiji in 2011 to that in 2012?
Ensure brevity in your answer.  1. What is the ratio of the Cost (US$ per container) in Malaysia in 2011 to that in 2012?
Provide a succinct answer. 1.04. What is the ratio of the Cost (US$ per container) of Pacific island small states in 2011 to that in 2013?
Your answer should be compact. 1.01. What is the ratio of the Cost (US$ per container) of Fiji in 2011 to that in 2013?
Keep it short and to the point. 0.83. What is the ratio of the Cost (US$ per container) of Malaysia in 2011 to that in 2013?
Keep it short and to the point. 0.9. What is the ratio of the Cost (US$ per container) of Pacific island small states in 2012 to that in 2013?
Provide a succinct answer. 0.98. What is the ratio of the Cost (US$ per container) in Fiji in 2012 to that in 2013?
Give a very brief answer. 0.83. What is the ratio of the Cost (US$ per container) of Malaysia in 2012 to that in 2013?
Offer a terse response. 0.87. What is the difference between the highest and the second highest Cost (US$ per container) in Pacific island small states?
Your response must be concise. 189.11. What is the difference between the highest and the second highest Cost (US$ per container) of Fiji?
Offer a terse response. 125. What is the difference between the highest and the second highest Cost (US$ per container) in Malaysia?
Provide a short and direct response. 35. What is the difference between the highest and the lowest Cost (US$ per container) of Pacific island small states?
Offer a terse response. 345.67. What is the difference between the highest and the lowest Cost (US$ per container) in Fiji?
Your answer should be very brief. 190. What is the difference between the highest and the lowest Cost (US$ per container) of Malaysia?
Keep it short and to the point. 100. 